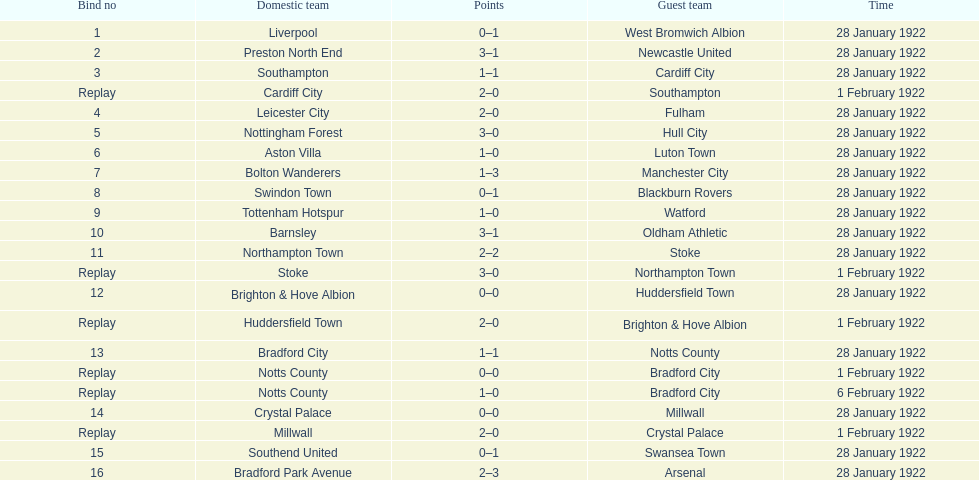How many games had no points scored? 3. 